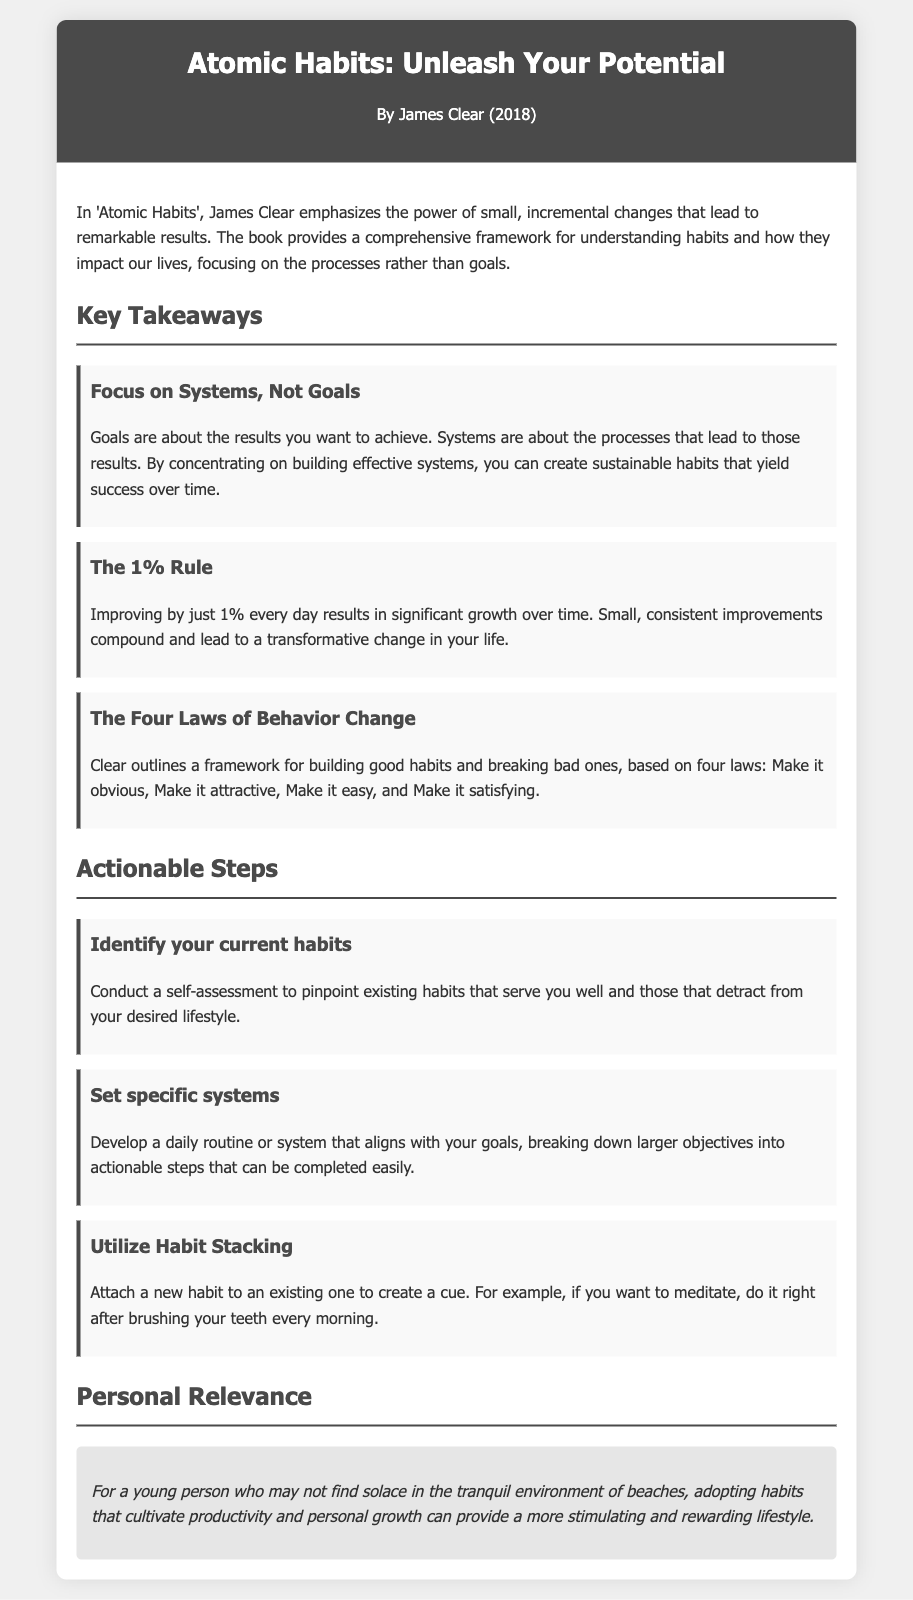What is the title of the book? The title of the book is mentioned prominently in the header of the document.
Answer: Atomic Habits: Unleash Your Potential Who is the author of the book? The author’s name is provided right below the title in the header section.
Answer: James Clear What is the year of publication? The year of publication is indicated in the header along with the author's name.
Answer: 2018 What is the main focus of 'Atomic Habits'? The document provides a summary of what the book emphasizes at the beginning of the content section.
Answer: Small, incremental changes What are the Four Laws of Behavior Change? This question requires combining information about the framework presented in the takeaways section.
Answer: Make it obvious, Make it attractive, Make it easy, Make it satisfying What is the 1% Rule? The answer can be inferred from the explanation found in the key takeaways section.
Answer: Improving by just 1% every day What is one actionable step suggested in the document? The document lists several actionable steps under a specific section, any of which could be correct.
Answer: Identify your current habits What does habit stacking refer to? The document contains a description of habit stacking in the actionable steps section.
Answer: Attach a new habit to an existing one How can young people benefit from the book's message? This question refers to the personal relevance section that discusses how the book can apply to a specific demographic.
Answer: Cultivate productivity and personal growth 